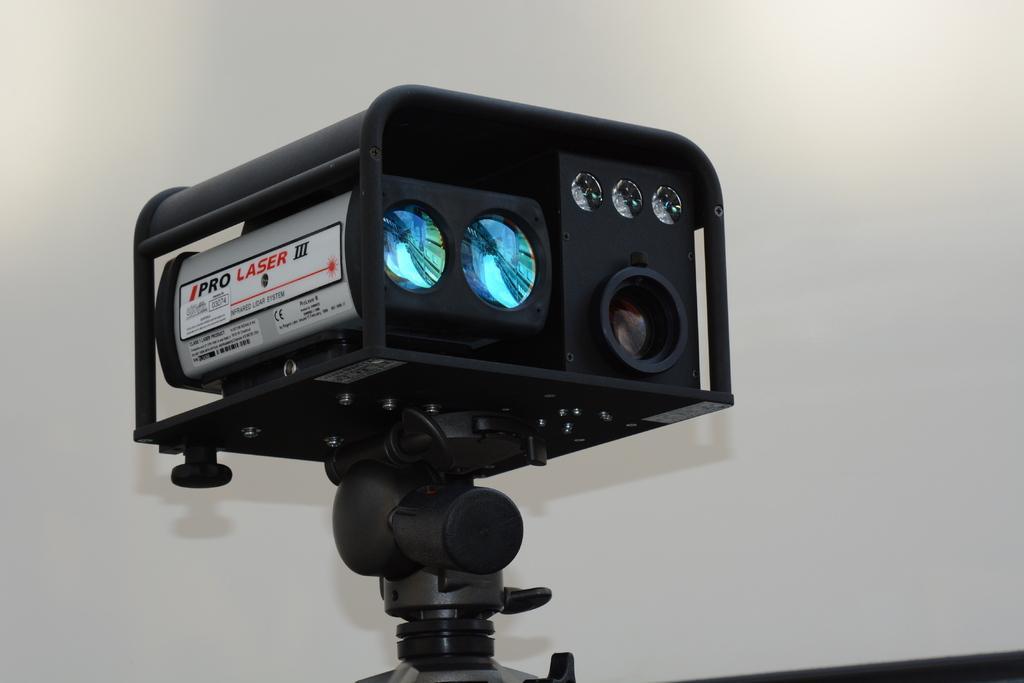Describe this image in one or two sentences. This picture contains a camcorder. It is in black color. In the background, we see a wall in white color. 